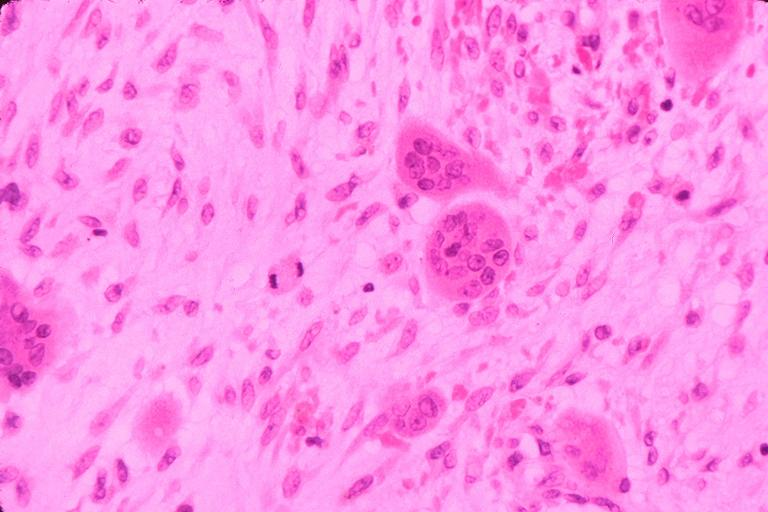does dysplastic show cherubism?
Answer the question using a single word or phrase. No 